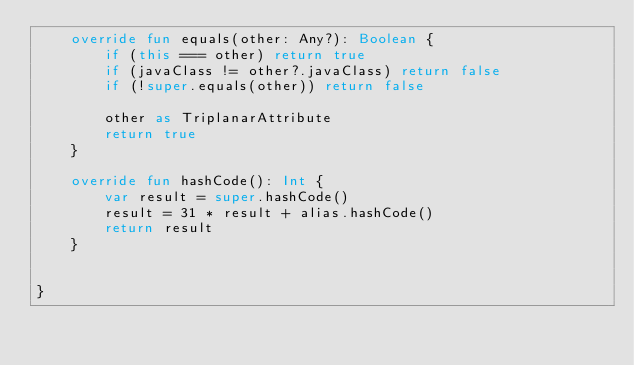<code> <loc_0><loc_0><loc_500><loc_500><_Kotlin_>    override fun equals(other: Any?): Boolean {
        if (this === other) return true
        if (javaClass != other?.javaClass) return false
        if (!super.equals(other)) return false

        other as TriplanarAttribute
        return true
    }

    override fun hashCode(): Int {
        var result = super.hashCode()
        result = 31 * result + alias.hashCode()
        return result
    }


}</code> 